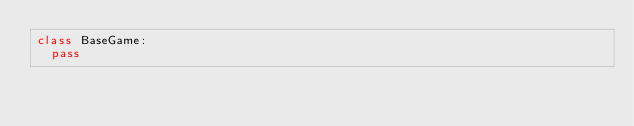Convert code to text. <code><loc_0><loc_0><loc_500><loc_500><_Python_>class BaseGame:
	pass</code> 